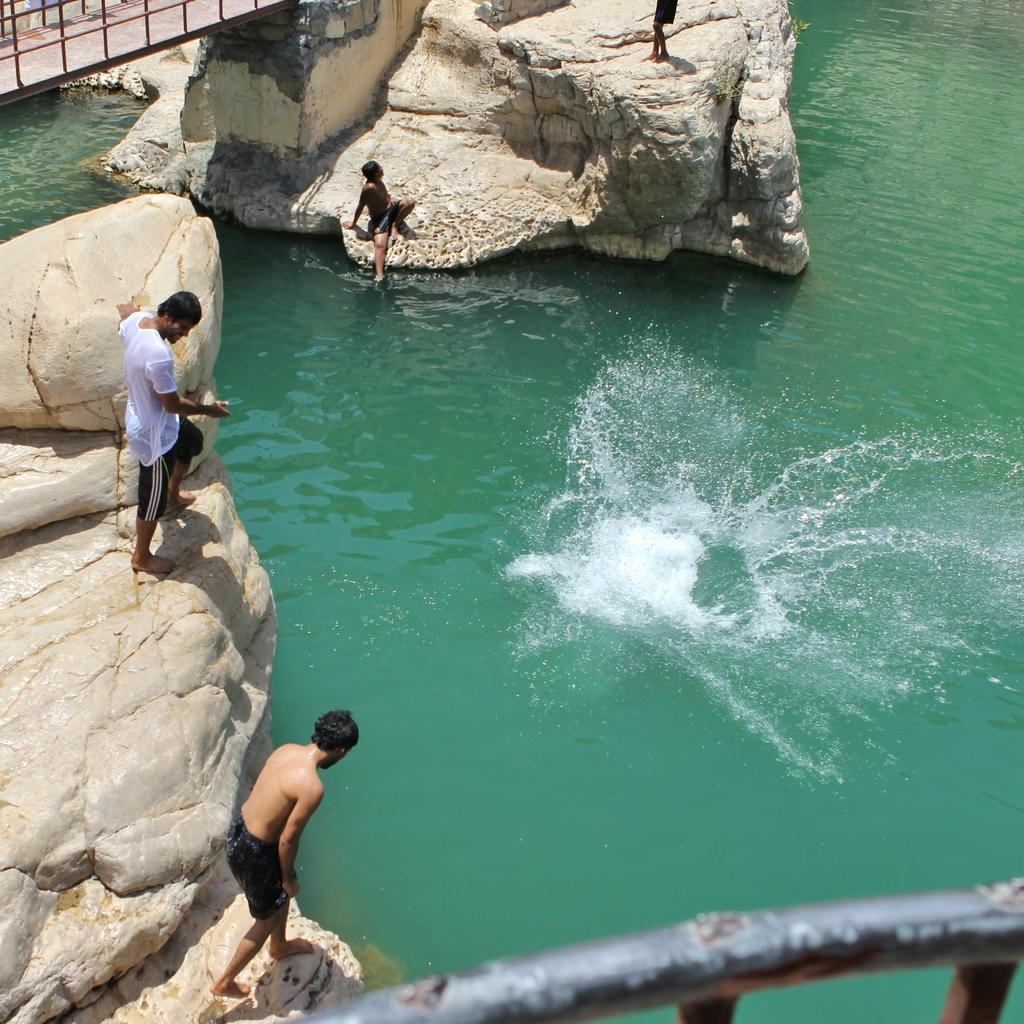What are the people in the image doing? The people in the image are standing on rocks. What body of water is visible in the image? There is a pond in the image. What structure can be seen on the top left side of the image? There is a railing on the top left side of the image. What angle is the sun shining from in the image? The facts provided do not mention the angle of the sun or any information about the time of day or season, so it cannot be determined from the image. 